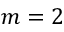<formula> <loc_0><loc_0><loc_500><loc_500>m = 2</formula> 